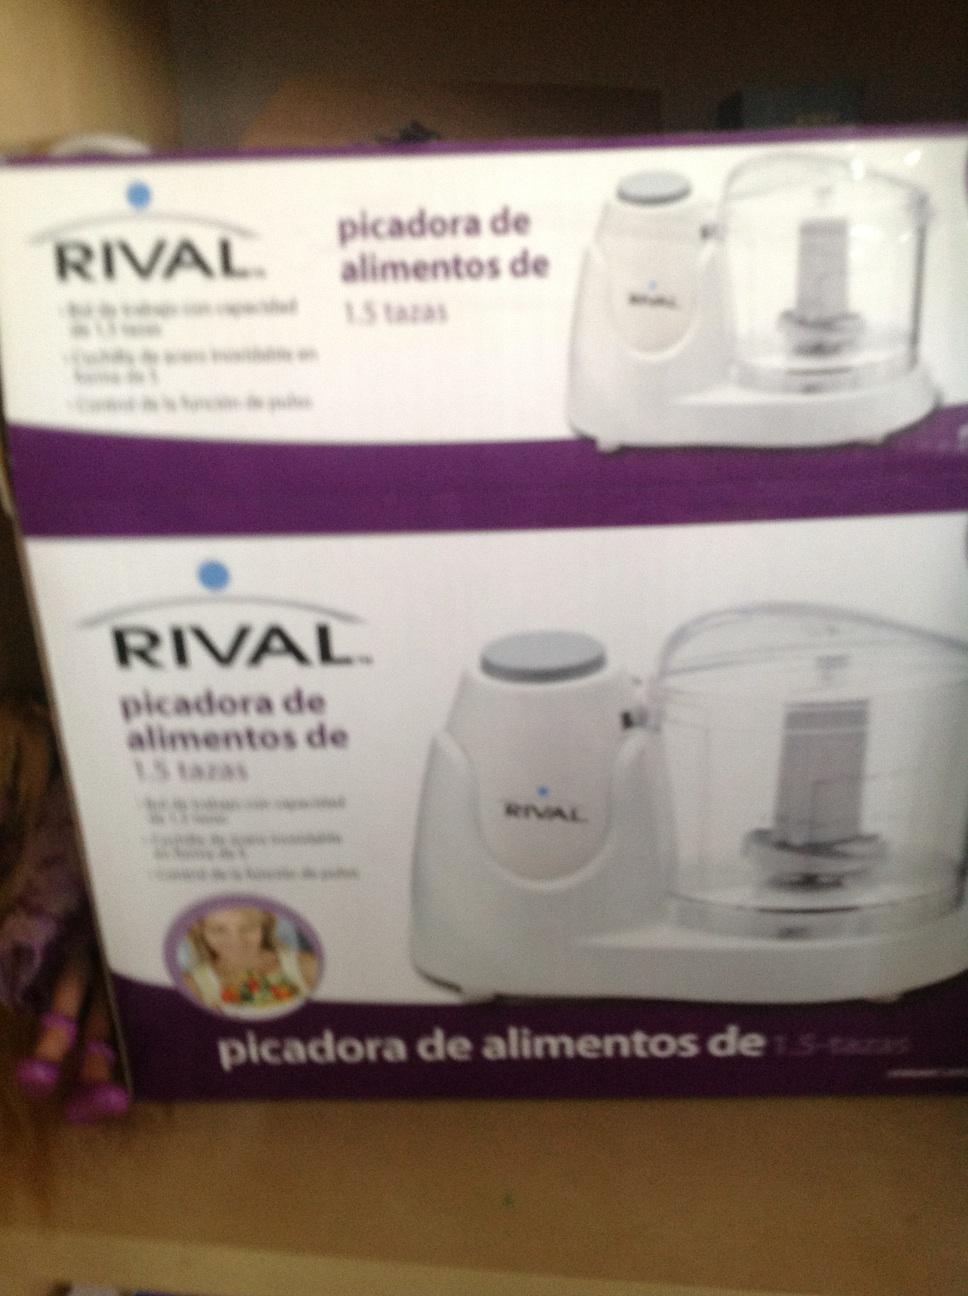What would be the ideal scenario to use this food chopper? An ideal scenario for using this RIVAL food chopper would be preparing a quick family meal. Imagine you need to chop onions, garlic, and peppers for a stir-fry. Instead of manually chopping everything, you can use this appliance to get everything done quickly and uniformly. It would save time and ensure that all ingredients are evenly chopped, enhancing the overall quality of your dish. 